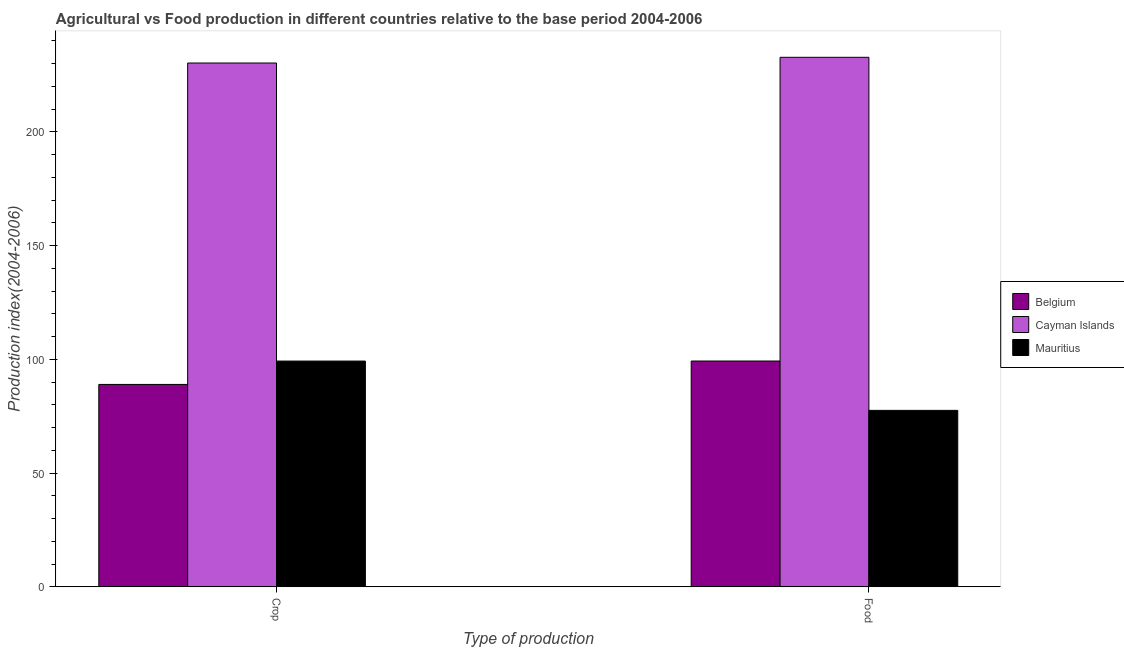How many different coloured bars are there?
Offer a very short reply. 3. Are the number of bars on each tick of the X-axis equal?
Offer a terse response. Yes. How many bars are there on the 1st tick from the right?
Make the answer very short. 3. What is the label of the 1st group of bars from the left?
Your answer should be very brief. Crop. What is the crop production index in Mauritius?
Your response must be concise. 99.21. Across all countries, what is the maximum crop production index?
Keep it short and to the point. 230.24. Across all countries, what is the minimum crop production index?
Your answer should be very brief. 88.94. In which country was the crop production index maximum?
Your response must be concise. Cayman Islands. In which country was the food production index minimum?
Make the answer very short. Mauritius. What is the total crop production index in the graph?
Your answer should be compact. 418.39. What is the difference between the crop production index in Belgium and that in Mauritius?
Your answer should be very brief. -10.27. What is the difference between the crop production index in Belgium and the food production index in Mauritius?
Ensure brevity in your answer.  11.4. What is the average food production index per country?
Provide a succinct answer. 136.51. What is the difference between the crop production index and food production index in Cayman Islands?
Ensure brevity in your answer.  -2.51. In how many countries, is the food production index greater than 40 ?
Offer a very short reply. 3. What is the ratio of the food production index in Mauritius to that in Cayman Islands?
Keep it short and to the point. 0.33. Is the crop production index in Belgium less than that in Cayman Islands?
Your response must be concise. Yes. What does the 2nd bar from the left in Crop represents?
Offer a very short reply. Cayman Islands. What is the difference between two consecutive major ticks on the Y-axis?
Your answer should be very brief. 50. What is the title of the graph?
Offer a terse response. Agricultural vs Food production in different countries relative to the base period 2004-2006. What is the label or title of the X-axis?
Your response must be concise. Type of production. What is the label or title of the Y-axis?
Provide a short and direct response. Production index(2004-2006). What is the Production index(2004-2006) of Belgium in Crop?
Offer a very short reply. 88.94. What is the Production index(2004-2006) in Cayman Islands in Crop?
Ensure brevity in your answer.  230.24. What is the Production index(2004-2006) of Mauritius in Crop?
Give a very brief answer. 99.21. What is the Production index(2004-2006) of Belgium in Food?
Give a very brief answer. 99.23. What is the Production index(2004-2006) in Cayman Islands in Food?
Your answer should be compact. 232.75. What is the Production index(2004-2006) in Mauritius in Food?
Your answer should be very brief. 77.54. Across all Type of production, what is the maximum Production index(2004-2006) of Belgium?
Provide a short and direct response. 99.23. Across all Type of production, what is the maximum Production index(2004-2006) in Cayman Islands?
Provide a succinct answer. 232.75. Across all Type of production, what is the maximum Production index(2004-2006) in Mauritius?
Give a very brief answer. 99.21. Across all Type of production, what is the minimum Production index(2004-2006) in Belgium?
Provide a short and direct response. 88.94. Across all Type of production, what is the minimum Production index(2004-2006) of Cayman Islands?
Make the answer very short. 230.24. Across all Type of production, what is the minimum Production index(2004-2006) in Mauritius?
Offer a very short reply. 77.54. What is the total Production index(2004-2006) in Belgium in the graph?
Provide a short and direct response. 188.17. What is the total Production index(2004-2006) of Cayman Islands in the graph?
Keep it short and to the point. 462.99. What is the total Production index(2004-2006) of Mauritius in the graph?
Your response must be concise. 176.75. What is the difference between the Production index(2004-2006) of Belgium in Crop and that in Food?
Make the answer very short. -10.29. What is the difference between the Production index(2004-2006) of Cayman Islands in Crop and that in Food?
Make the answer very short. -2.51. What is the difference between the Production index(2004-2006) in Mauritius in Crop and that in Food?
Your response must be concise. 21.67. What is the difference between the Production index(2004-2006) in Belgium in Crop and the Production index(2004-2006) in Cayman Islands in Food?
Keep it short and to the point. -143.81. What is the difference between the Production index(2004-2006) in Cayman Islands in Crop and the Production index(2004-2006) in Mauritius in Food?
Ensure brevity in your answer.  152.7. What is the average Production index(2004-2006) in Belgium per Type of production?
Your response must be concise. 94.08. What is the average Production index(2004-2006) of Cayman Islands per Type of production?
Your answer should be compact. 231.5. What is the average Production index(2004-2006) of Mauritius per Type of production?
Give a very brief answer. 88.38. What is the difference between the Production index(2004-2006) in Belgium and Production index(2004-2006) in Cayman Islands in Crop?
Make the answer very short. -141.3. What is the difference between the Production index(2004-2006) in Belgium and Production index(2004-2006) in Mauritius in Crop?
Provide a succinct answer. -10.27. What is the difference between the Production index(2004-2006) in Cayman Islands and Production index(2004-2006) in Mauritius in Crop?
Make the answer very short. 131.03. What is the difference between the Production index(2004-2006) of Belgium and Production index(2004-2006) of Cayman Islands in Food?
Make the answer very short. -133.52. What is the difference between the Production index(2004-2006) of Belgium and Production index(2004-2006) of Mauritius in Food?
Provide a short and direct response. 21.69. What is the difference between the Production index(2004-2006) of Cayman Islands and Production index(2004-2006) of Mauritius in Food?
Your answer should be very brief. 155.21. What is the ratio of the Production index(2004-2006) in Belgium in Crop to that in Food?
Give a very brief answer. 0.9. What is the ratio of the Production index(2004-2006) of Mauritius in Crop to that in Food?
Your response must be concise. 1.28. What is the difference between the highest and the second highest Production index(2004-2006) of Belgium?
Your response must be concise. 10.29. What is the difference between the highest and the second highest Production index(2004-2006) in Cayman Islands?
Your answer should be very brief. 2.51. What is the difference between the highest and the second highest Production index(2004-2006) of Mauritius?
Provide a succinct answer. 21.67. What is the difference between the highest and the lowest Production index(2004-2006) of Belgium?
Offer a terse response. 10.29. What is the difference between the highest and the lowest Production index(2004-2006) in Cayman Islands?
Offer a terse response. 2.51. What is the difference between the highest and the lowest Production index(2004-2006) in Mauritius?
Your answer should be very brief. 21.67. 